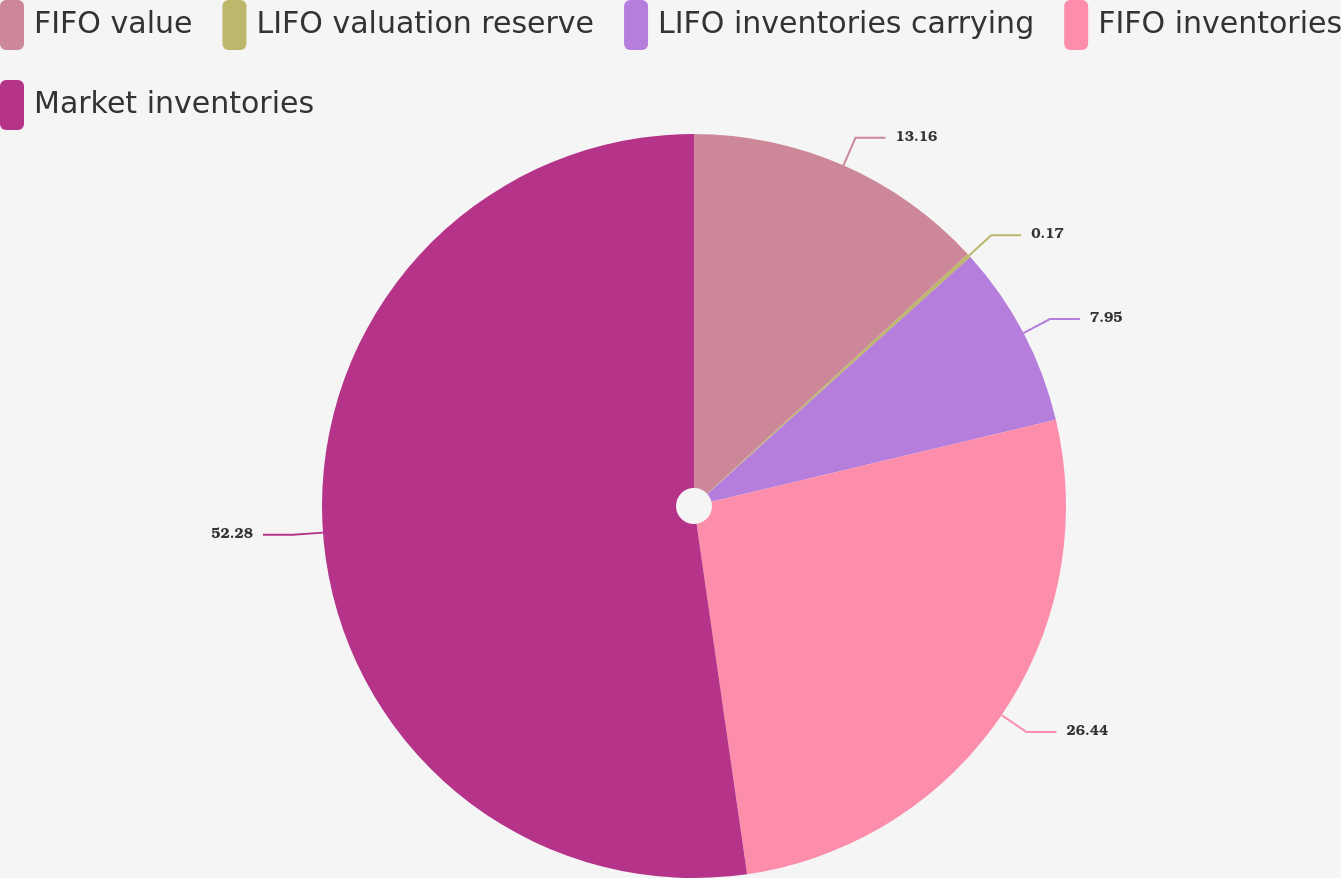Convert chart. <chart><loc_0><loc_0><loc_500><loc_500><pie_chart><fcel>FIFO value<fcel>LIFO valuation reserve<fcel>LIFO inventories carrying<fcel>FIFO inventories<fcel>Market inventories<nl><fcel>13.16%<fcel>0.17%<fcel>7.95%<fcel>26.44%<fcel>52.28%<nl></chart> 